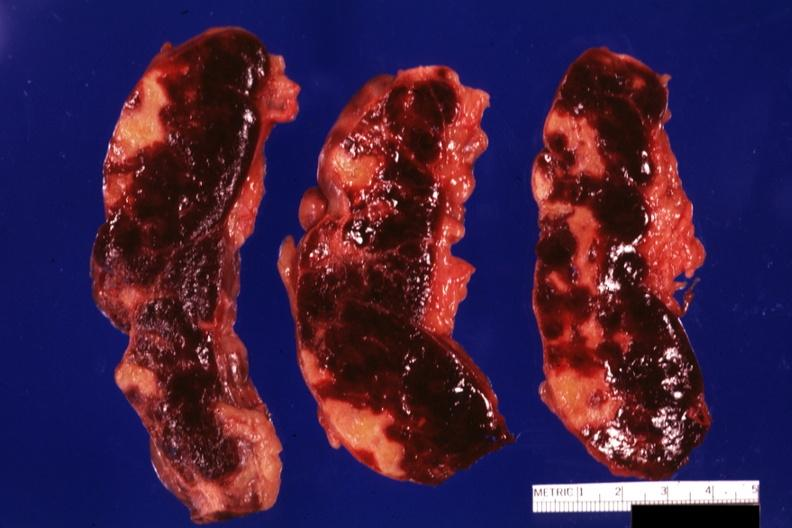s excellent gangrenous necrosis of fingers present?
Answer the question using a single word or phrase. No 